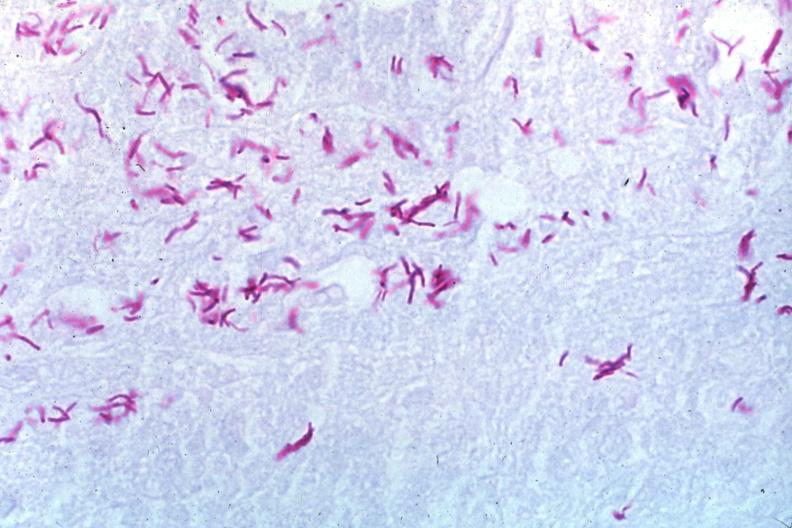does carcinoma show oil acid fast stain a zillion organisms?
Answer the question using a single word or phrase. No 